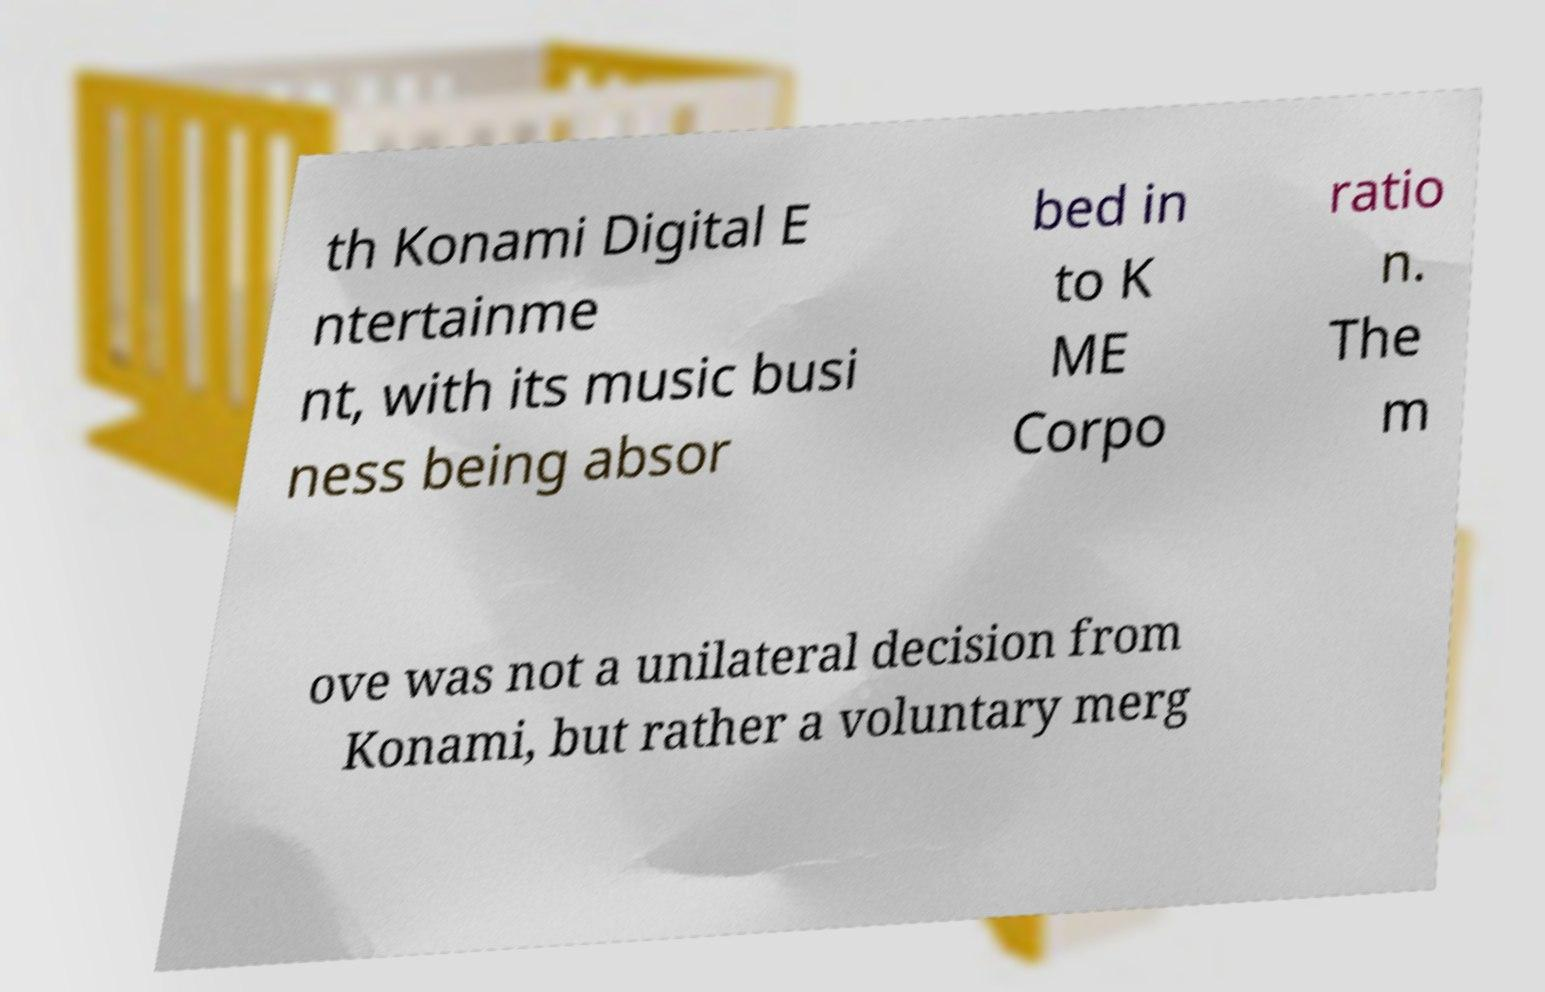Please read and relay the text visible in this image. What does it say? th Konami Digital E ntertainme nt, with its music busi ness being absor bed in to K ME Corpo ratio n. The m ove was not a unilateral decision from Konami, but rather a voluntary merg 